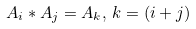<formula> <loc_0><loc_0><loc_500><loc_500>A _ { i } * A _ { j } = A _ { k } , \, k = \left ( i + j \right )</formula> 